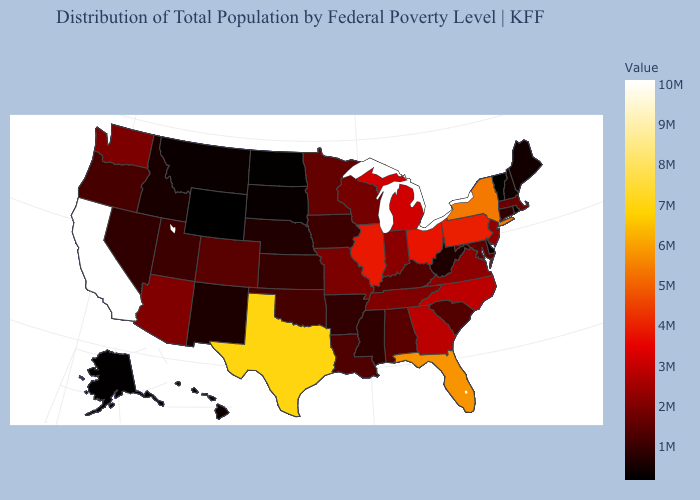Which states hav the highest value in the West?
Short answer required. California. Among the states that border Colorado , does Wyoming have the lowest value?
Short answer required. Yes. Is the legend a continuous bar?
Quick response, please. Yes. Which states have the lowest value in the USA?
Short answer required. Wyoming. Among the states that border West Virginia , which have the lowest value?
Give a very brief answer. Kentucky. 